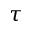Convert formula to latex. <formula><loc_0><loc_0><loc_500><loc_500>\tau</formula> 